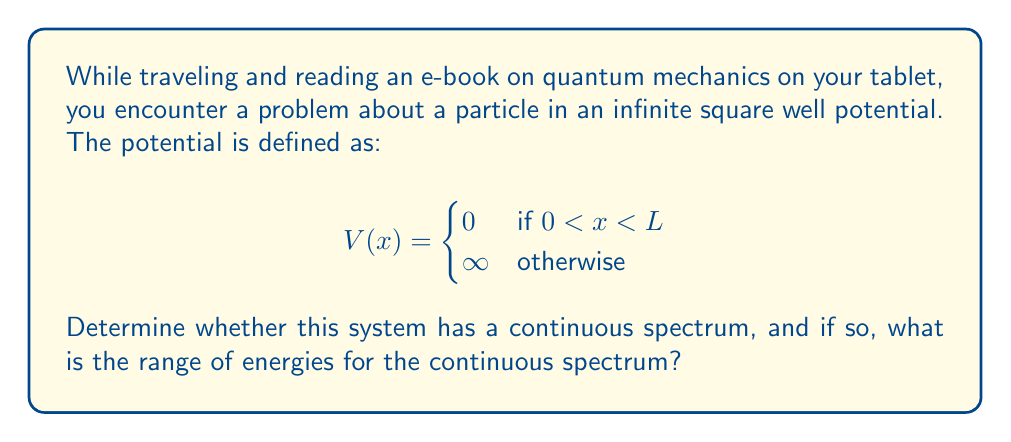Give your solution to this math problem. Let's approach this step-by-step:

1) The continuous spectrum in quantum mechanics refers to a range of energies that a system can have without restriction to discrete values.

2) For a particle in an infinite square well, we need to solve the time-independent Schrödinger equation:

   $$-\frac{\hbar^2}{2m}\frac{d^2\psi}{dx^2} + V(x)\psi = E\psi$$

3) Inside the well (0 < x < L), V(x) = 0, so the equation becomes:

   $$-\frac{\hbar^2}{2m}\frac{d^2\psi}{dx^2} = E\psi$$

4) The general solution to this equation is:

   $$\psi(x) = A\sin(kx) + B\cos(kx)$$

   where $k = \sqrt{\frac{2mE}{\hbar^2}}$

5) The boundary conditions require that $\psi(0) = \psi(L) = 0$, which leads to:

   $$\psi(x) = A\sin(\frac{n\pi x}{L})$$

   where n is a positive integer.

6) The energy eigenvalues are:

   $$E_n = \frac{n^2\pi^2\hbar^2}{2mL^2}$$

7) As we can see, the energy values are discrete and depend on the integer n. There are no energy values between these discrete levels.

8) Therefore, this system does not have a continuous spectrum. It only has a discrete spectrum.

9) The energies range from the ground state (n=1) to infinity as n approaches infinity, but they remain discrete.
Answer: No continuous spectrum; only discrete energy levels $E_n = \frac{n^2\pi^2\hbar^2}{2mL^2}$ where n is a positive integer. 